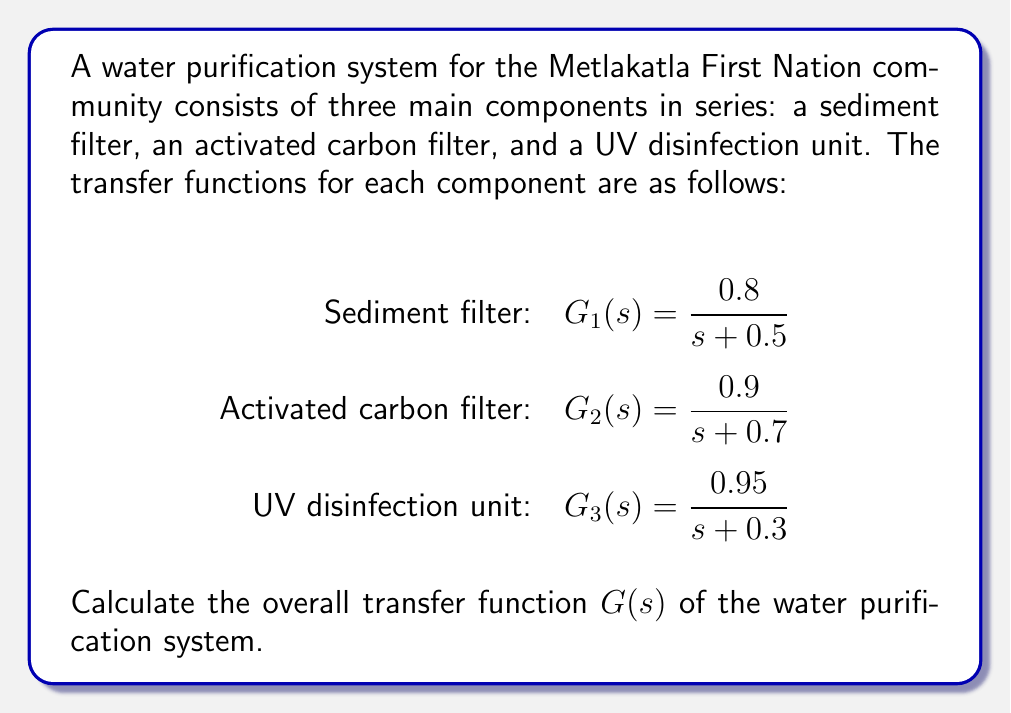Teach me how to tackle this problem. To calculate the overall transfer function of the water purification system, we need to multiply the individual transfer functions of the components in series. This is because the output of each component becomes the input of the next component in the system.

Let's follow these steps:

1) The overall transfer function $G(s)$ is given by:

   $G(s) = G_1(s) \cdot G_2(s) \cdot G_3(s)$

2) Substitute the given transfer functions:

   $G(s) = \frac{0.8}{s + 0.5} \cdot \frac{0.9}{s + 0.7} \cdot \frac{0.95}{s + 0.3}$

3) Multiply the numerators and denominators:

   $G(s) = \frac{0.8 \cdot 0.9 \cdot 0.95}{(s + 0.5)(s + 0.7)(s + 0.3)}$

4) Simplify the numerator:

   $G(s) = \frac{0.684}{(s + 0.5)(s + 0.7)(s + 0.3)}$

5) Expand the denominator:

   $G(s) = \frac{0.684}{s^3 + 1.5s^2 + 0.71s + 0.105}$

This is the overall transfer function of the water purification system.
Answer: $G(s) = \frac{0.684}{s^3 + 1.5s^2 + 0.71s + 0.105}$ 